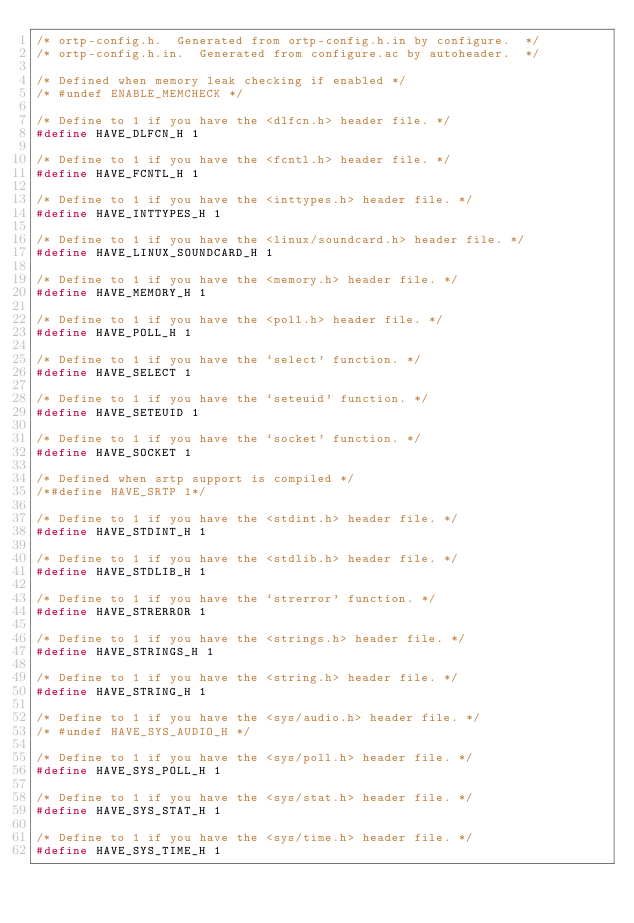Convert code to text. <code><loc_0><loc_0><loc_500><loc_500><_C_>/* ortp-config.h.  Generated from ortp-config.h.in by configure.  */
/* ortp-config.h.in.  Generated from configure.ac by autoheader.  */

/* Defined when memory leak checking if enabled */
/* #undef ENABLE_MEMCHECK */

/* Define to 1 if you have the <dlfcn.h> header file. */
#define HAVE_DLFCN_H 1

/* Define to 1 if you have the <fcntl.h> header file. */
#define HAVE_FCNTL_H 1

/* Define to 1 if you have the <inttypes.h> header file. */
#define HAVE_INTTYPES_H 1

/* Define to 1 if you have the <linux/soundcard.h> header file. */
#define HAVE_LINUX_SOUNDCARD_H 1

/* Define to 1 if you have the <memory.h> header file. */
#define HAVE_MEMORY_H 1

/* Define to 1 if you have the <poll.h> header file. */
#define HAVE_POLL_H 1

/* Define to 1 if you have the `select' function. */
#define HAVE_SELECT 1

/* Define to 1 if you have the `seteuid' function. */
#define HAVE_SETEUID 1

/* Define to 1 if you have the `socket' function. */
#define HAVE_SOCKET 1

/* Defined when srtp support is compiled */
/*#define HAVE_SRTP 1*/

/* Define to 1 if you have the <stdint.h> header file. */
#define HAVE_STDINT_H 1

/* Define to 1 if you have the <stdlib.h> header file. */
#define HAVE_STDLIB_H 1

/* Define to 1 if you have the `strerror' function. */
#define HAVE_STRERROR 1

/* Define to 1 if you have the <strings.h> header file. */
#define HAVE_STRINGS_H 1

/* Define to 1 if you have the <string.h> header file. */
#define HAVE_STRING_H 1

/* Define to 1 if you have the <sys/audio.h> header file. */
/* #undef HAVE_SYS_AUDIO_H */

/* Define to 1 if you have the <sys/poll.h> header file. */
#define HAVE_SYS_POLL_H 1

/* Define to 1 if you have the <sys/stat.h> header file. */
#define HAVE_SYS_STAT_H 1

/* Define to 1 if you have the <sys/time.h> header file. */
#define HAVE_SYS_TIME_H 1
</code> 